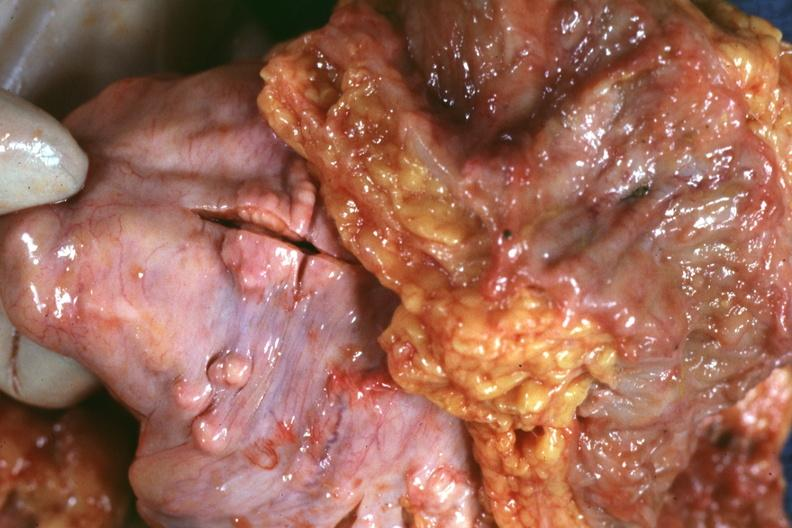what is present?
Answer the question using a single word or phrase. Metastatic carcinoma prostate 